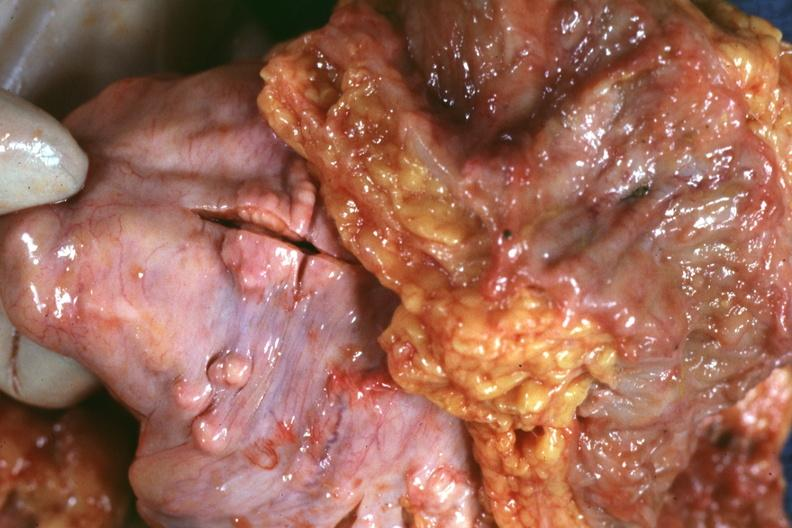what is present?
Answer the question using a single word or phrase. Metastatic carcinoma prostate 